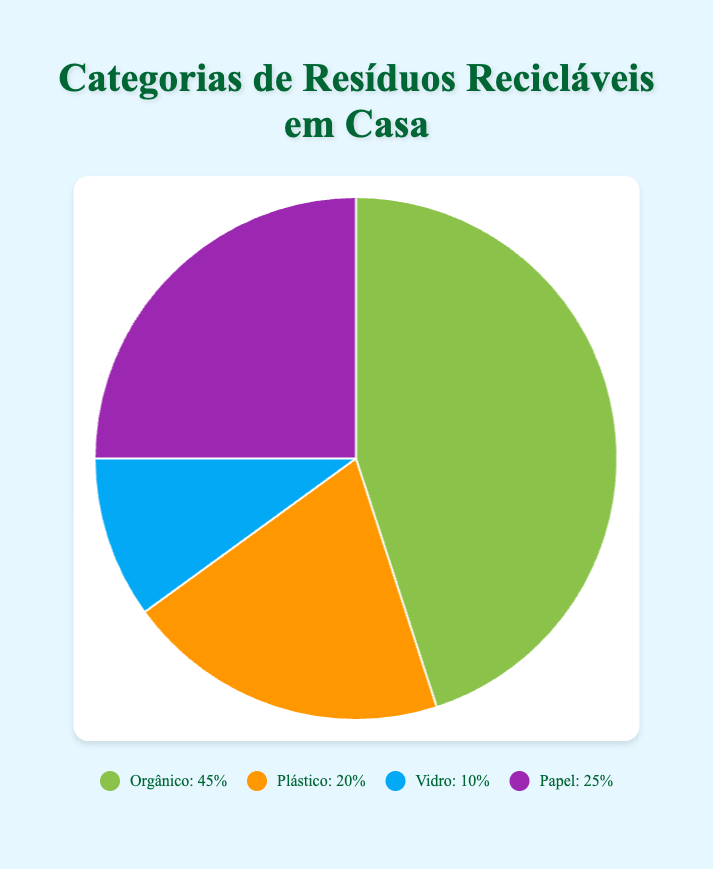Which category makes up the largest portion of recycling waste? The "Organic" category makes up the largest portion of recycling waste at 45%.
Answer: Organic Which category has the smallest portion of recycling waste? The "Glass" category has the smallest portion of recycling waste at 10%.
Answer: Glass What percentage of recycling waste categories do Plastic and Paper together make up? The percentage of recycling waste for Plastic is 20%, and for Paper is 25%. Combined, Plastic and Paper make up 20% + 25% = 45% of the total recycling waste.
Answer: 45% How does the percentage of Glass waste compare to Paper waste? The percentage of Glass waste is 10%, while Paper waste is 25%. Therefore, Paper waste is more than double (25% > 10%) the Glass waste.
Answer: Paper waste is more than double What percentage of recycling waste comes from non-organic categories? The non-organic categories are Plastic (20%), Glass (10%), and Paper (25%). Their combined percentage is 20% + 10% + 25% = 55%.
Answer: 55% Which category has the closest percentage to Plastic waste? Paper waste is closest to Plastic waste, with Paper at 25% and Plastic at 20%, which is a difference of 5%.
Answer: Paper If Organic waste is halved, would it still be the largest category? If the Organic waste is halved, it would be 45% / 2 = 22.5%. The largest remaining category would be Paper at 25%. Therefore, Organic would no longer be the largest category.
Answer: No Is the combined percentage of Plastic and Glass waste more or less than the percentage of Organic waste? The combined percentage of Plastic (20%) and Glass (10%) is 20% + 10% = 30%. This is less than the percentage of Organic waste which is 45%.
Answer: Less What color represents the Paper category in the pie chart? The Paper category is represented by the purple color in the pie chart.
Answer: Purple 